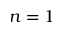<formula> <loc_0><loc_0><loc_500><loc_500>n = 1</formula> 